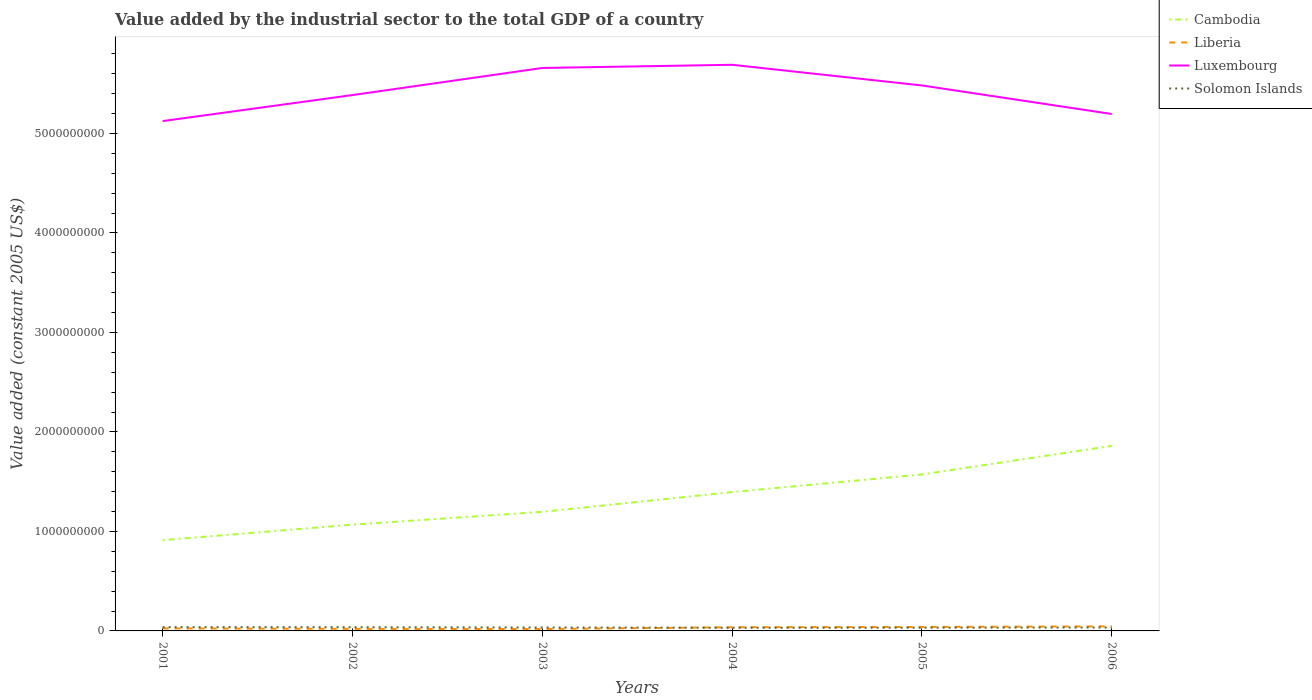How many different coloured lines are there?
Give a very brief answer. 4. Is the number of lines equal to the number of legend labels?
Offer a terse response. Yes. Across all years, what is the maximum value added by the industrial sector in Liberia?
Your response must be concise. 1.89e+07. What is the total value added by the industrial sector in Luxembourg in the graph?
Offer a very short reply. 4.95e+08. What is the difference between the highest and the second highest value added by the industrial sector in Liberia?
Ensure brevity in your answer.  2.71e+07. How many lines are there?
Ensure brevity in your answer.  4. How many years are there in the graph?
Your answer should be very brief. 6. What is the difference between two consecutive major ticks on the Y-axis?
Give a very brief answer. 1.00e+09. Are the values on the major ticks of Y-axis written in scientific E-notation?
Your answer should be compact. No. How many legend labels are there?
Offer a very short reply. 4. What is the title of the graph?
Provide a succinct answer. Value added by the industrial sector to the total GDP of a country. Does "Central Europe" appear as one of the legend labels in the graph?
Ensure brevity in your answer.  No. What is the label or title of the Y-axis?
Keep it short and to the point. Value added (constant 2005 US$). What is the Value added (constant 2005 US$) of Cambodia in 2001?
Offer a very short reply. 9.12e+08. What is the Value added (constant 2005 US$) of Liberia in 2001?
Provide a short and direct response. 2.54e+07. What is the Value added (constant 2005 US$) of Luxembourg in 2001?
Your answer should be very brief. 5.12e+09. What is the Value added (constant 2005 US$) in Solomon Islands in 2001?
Offer a very short reply. 3.80e+07. What is the Value added (constant 2005 US$) of Cambodia in 2002?
Give a very brief answer. 1.07e+09. What is the Value added (constant 2005 US$) in Liberia in 2002?
Your response must be concise. 2.10e+07. What is the Value added (constant 2005 US$) of Luxembourg in 2002?
Make the answer very short. 5.39e+09. What is the Value added (constant 2005 US$) of Solomon Islands in 2002?
Give a very brief answer. 3.70e+07. What is the Value added (constant 2005 US$) in Cambodia in 2003?
Provide a short and direct response. 1.20e+09. What is the Value added (constant 2005 US$) in Liberia in 2003?
Offer a very short reply. 1.89e+07. What is the Value added (constant 2005 US$) in Luxembourg in 2003?
Provide a short and direct response. 5.66e+09. What is the Value added (constant 2005 US$) in Solomon Islands in 2003?
Your response must be concise. 3.43e+07. What is the Value added (constant 2005 US$) of Cambodia in 2004?
Provide a short and direct response. 1.40e+09. What is the Value added (constant 2005 US$) of Liberia in 2004?
Ensure brevity in your answer.  3.69e+07. What is the Value added (constant 2005 US$) of Luxembourg in 2004?
Ensure brevity in your answer.  5.69e+09. What is the Value added (constant 2005 US$) of Solomon Islands in 2004?
Give a very brief answer. 3.20e+07. What is the Value added (constant 2005 US$) in Cambodia in 2005?
Keep it short and to the point. 1.57e+09. What is the Value added (constant 2005 US$) of Liberia in 2005?
Offer a very short reply. 3.97e+07. What is the Value added (constant 2005 US$) in Luxembourg in 2005?
Your response must be concise. 5.48e+09. What is the Value added (constant 2005 US$) in Solomon Islands in 2005?
Make the answer very short. 3.29e+07. What is the Value added (constant 2005 US$) in Cambodia in 2006?
Ensure brevity in your answer.  1.86e+09. What is the Value added (constant 2005 US$) of Liberia in 2006?
Provide a short and direct response. 4.59e+07. What is the Value added (constant 2005 US$) in Luxembourg in 2006?
Provide a short and direct response. 5.20e+09. What is the Value added (constant 2005 US$) in Solomon Islands in 2006?
Ensure brevity in your answer.  3.43e+07. Across all years, what is the maximum Value added (constant 2005 US$) of Cambodia?
Your response must be concise. 1.86e+09. Across all years, what is the maximum Value added (constant 2005 US$) in Liberia?
Make the answer very short. 4.59e+07. Across all years, what is the maximum Value added (constant 2005 US$) in Luxembourg?
Your answer should be compact. 5.69e+09. Across all years, what is the maximum Value added (constant 2005 US$) of Solomon Islands?
Ensure brevity in your answer.  3.80e+07. Across all years, what is the minimum Value added (constant 2005 US$) in Cambodia?
Make the answer very short. 9.12e+08. Across all years, what is the minimum Value added (constant 2005 US$) of Liberia?
Provide a succinct answer. 1.89e+07. Across all years, what is the minimum Value added (constant 2005 US$) of Luxembourg?
Offer a terse response. 5.12e+09. Across all years, what is the minimum Value added (constant 2005 US$) in Solomon Islands?
Ensure brevity in your answer.  3.20e+07. What is the total Value added (constant 2005 US$) of Cambodia in the graph?
Your answer should be very brief. 8.01e+09. What is the total Value added (constant 2005 US$) in Liberia in the graph?
Your response must be concise. 1.88e+08. What is the total Value added (constant 2005 US$) of Luxembourg in the graph?
Give a very brief answer. 3.25e+1. What is the total Value added (constant 2005 US$) of Solomon Islands in the graph?
Provide a short and direct response. 2.09e+08. What is the difference between the Value added (constant 2005 US$) of Cambodia in 2001 and that in 2002?
Ensure brevity in your answer.  -1.56e+08. What is the difference between the Value added (constant 2005 US$) in Liberia in 2001 and that in 2002?
Provide a succinct answer. 4.38e+06. What is the difference between the Value added (constant 2005 US$) of Luxembourg in 2001 and that in 2002?
Your response must be concise. -2.61e+08. What is the difference between the Value added (constant 2005 US$) of Solomon Islands in 2001 and that in 2002?
Give a very brief answer. 9.35e+05. What is the difference between the Value added (constant 2005 US$) of Cambodia in 2001 and that in 2003?
Make the answer very short. -2.84e+08. What is the difference between the Value added (constant 2005 US$) in Liberia in 2001 and that in 2003?
Your answer should be compact. 6.53e+06. What is the difference between the Value added (constant 2005 US$) of Luxembourg in 2001 and that in 2003?
Provide a succinct answer. -5.34e+08. What is the difference between the Value added (constant 2005 US$) of Solomon Islands in 2001 and that in 2003?
Your response must be concise. 3.68e+06. What is the difference between the Value added (constant 2005 US$) of Cambodia in 2001 and that in 2004?
Provide a succinct answer. -4.83e+08. What is the difference between the Value added (constant 2005 US$) of Liberia in 2001 and that in 2004?
Keep it short and to the point. -1.15e+07. What is the difference between the Value added (constant 2005 US$) in Luxembourg in 2001 and that in 2004?
Offer a very short reply. -5.66e+08. What is the difference between the Value added (constant 2005 US$) in Solomon Islands in 2001 and that in 2004?
Offer a terse response. 5.93e+06. What is the difference between the Value added (constant 2005 US$) in Cambodia in 2001 and that in 2005?
Provide a succinct answer. -6.60e+08. What is the difference between the Value added (constant 2005 US$) in Liberia in 2001 and that in 2005?
Ensure brevity in your answer.  -1.43e+07. What is the difference between the Value added (constant 2005 US$) in Luxembourg in 2001 and that in 2005?
Ensure brevity in your answer.  -3.58e+08. What is the difference between the Value added (constant 2005 US$) in Solomon Islands in 2001 and that in 2005?
Your response must be concise. 5.08e+06. What is the difference between the Value added (constant 2005 US$) of Cambodia in 2001 and that in 2006?
Your answer should be very brief. -9.48e+08. What is the difference between the Value added (constant 2005 US$) in Liberia in 2001 and that in 2006?
Keep it short and to the point. -2.05e+07. What is the difference between the Value added (constant 2005 US$) in Luxembourg in 2001 and that in 2006?
Your answer should be compact. -7.12e+07. What is the difference between the Value added (constant 2005 US$) of Solomon Islands in 2001 and that in 2006?
Give a very brief answer. 3.71e+06. What is the difference between the Value added (constant 2005 US$) in Cambodia in 2002 and that in 2003?
Provide a short and direct response. -1.29e+08. What is the difference between the Value added (constant 2005 US$) in Liberia in 2002 and that in 2003?
Your response must be concise. 2.14e+06. What is the difference between the Value added (constant 2005 US$) of Luxembourg in 2002 and that in 2003?
Ensure brevity in your answer.  -2.72e+08. What is the difference between the Value added (constant 2005 US$) of Solomon Islands in 2002 and that in 2003?
Your answer should be very brief. 2.74e+06. What is the difference between the Value added (constant 2005 US$) of Cambodia in 2002 and that in 2004?
Your answer should be very brief. -3.27e+08. What is the difference between the Value added (constant 2005 US$) of Liberia in 2002 and that in 2004?
Offer a terse response. -1.59e+07. What is the difference between the Value added (constant 2005 US$) of Luxembourg in 2002 and that in 2004?
Your answer should be compact. -3.04e+08. What is the difference between the Value added (constant 2005 US$) in Solomon Islands in 2002 and that in 2004?
Provide a succinct answer. 5.00e+06. What is the difference between the Value added (constant 2005 US$) in Cambodia in 2002 and that in 2005?
Your response must be concise. -5.05e+08. What is the difference between the Value added (constant 2005 US$) in Liberia in 2002 and that in 2005?
Keep it short and to the point. -1.87e+07. What is the difference between the Value added (constant 2005 US$) in Luxembourg in 2002 and that in 2005?
Your response must be concise. -9.65e+07. What is the difference between the Value added (constant 2005 US$) of Solomon Islands in 2002 and that in 2005?
Offer a very short reply. 4.15e+06. What is the difference between the Value added (constant 2005 US$) in Cambodia in 2002 and that in 2006?
Offer a terse response. -7.92e+08. What is the difference between the Value added (constant 2005 US$) of Liberia in 2002 and that in 2006?
Make the answer very short. -2.49e+07. What is the difference between the Value added (constant 2005 US$) of Luxembourg in 2002 and that in 2006?
Your answer should be compact. 1.90e+08. What is the difference between the Value added (constant 2005 US$) in Solomon Islands in 2002 and that in 2006?
Offer a terse response. 2.78e+06. What is the difference between the Value added (constant 2005 US$) of Cambodia in 2003 and that in 2004?
Your response must be concise. -1.99e+08. What is the difference between the Value added (constant 2005 US$) of Liberia in 2003 and that in 2004?
Provide a succinct answer. -1.81e+07. What is the difference between the Value added (constant 2005 US$) in Luxembourg in 2003 and that in 2004?
Ensure brevity in your answer.  -3.20e+07. What is the difference between the Value added (constant 2005 US$) of Solomon Islands in 2003 and that in 2004?
Offer a very short reply. 2.26e+06. What is the difference between the Value added (constant 2005 US$) of Cambodia in 2003 and that in 2005?
Ensure brevity in your answer.  -3.76e+08. What is the difference between the Value added (constant 2005 US$) of Liberia in 2003 and that in 2005?
Make the answer very short. -2.08e+07. What is the difference between the Value added (constant 2005 US$) in Luxembourg in 2003 and that in 2005?
Give a very brief answer. 1.76e+08. What is the difference between the Value added (constant 2005 US$) in Solomon Islands in 2003 and that in 2005?
Offer a very short reply. 1.41e+06. What is the difference between the Value added (constant 2005 US$) in Cambodia in 2003 and that in 2006?
Offer a very short reply. -6.63e+08. What is the difference between the Value added (constant 2005 US$) in Liberia in 2003 and that in 2006?
Offer a very short reply. -2.71e+07. What is the difference between the Value added (constant 2005 US$) of Luxembourg in 2003 and that in 2006?
Your answer should be compact. 4.63e+08. What is the difference between the Value added (constant 2005 US$) of Solomon Islands in 2003 and that in 2006?
Your answer should be compact. 3.70e+04. What is the difference between the Value added (constant 2005 US$) in Cambodia in 2004 and that in 2005?
Your response must be concise. -1.77e+08. What is the difference between the Value added (constant 2005 US$) in Liberia in 2004 and that in 2005?
Your answer should be compact. -2.78e+06. What is the difference between the Value added (constant 2005 US$) of Luxembourg in 2004 and that in 2005?
Provide a short and direct response. 2.08e+08. What is the difference between the Value added (constant 2005 US$) of Solomon Islands in 2004 and that in 2005?
Offer a very short reply. -8.51e+05. What is the difference between the Value added (constant 2005 US$) of Cambodia in 2004 and that in 2006?
Your answer should be compact. -4.65e+08. What is the difference between the Value added (constant 2005 US$) of Liberia in 2004 and that in 2006?
Your answer should be very brief. -8.99e+06. What is the difference between the Value added (constant 2005 US$) in Luxembourg in 2004 and that in 2006?
Provide a short and direct response. 4.95e+08. What is the difference between the Value added (constant 2005 US$) in Solomon Islands in 2004 and that in 2006?
Provide a succinct answer. -2.22e+06. What is the difference between the Value added (constant 2005 US$) of Cambodia in 2005 and that in 2006?
Your answer should be very brief. -2.87e+08. What is the difference between the Value added (constant 2005 US$) of Liberia in 2005 and that in 2006?
Your response must be concise. -6.21e+06. What is the difference between the Value added (constant 2005 US$) in Luxembourg in 2005 and that in 2006?
Your response must be concise. 2.87e+08. What is the difference between the Value added (constant 2005 US$) in Solomon Islands in 2005 and that in 2006?
Your answer should be compact. -1.37e+06. What is the difference between the Value added (constant 2005 US$) of Cambodia in 2001 and the Value added (constant 2005 US$) of Liberia in 2002?
Ensure brevity in your answer.  8.91e+08. What is the difference between the Value added (constant 2005 US$) of Cambodia in 2001 and the Value added (constant 2005 US$) of Luxembourg in 2002?
Give a very brief answer. -4.47e+09. What is the difference between the Value added (constant 2005 US$) in Cambodia in 2001 and the Value added (constant 2005 US$) in Solomon Islands in 2002?
Provide a succinct answer. 8.75e+08. What is the difference between the Value added (constant 2005 US$) in Liberia in 2001 and the Value added (constant 2005 US$) in Luxembourg in 2002?
Offer a terse response. -5.36e+09. What is the difference between the Value added (constant 2005 US$) in Liberia in 2001 and the Value added (constant 2005 US$) in Solomon Islands in 2002?
Your answer should be very brief. -1.17e+07. What is the difference between the Value added (constant 2005 US$) of Luxembourg in 2001 and the Value added (constant 2005 US$) of Solomon Islands in 2002?
Your answer should be compact. 5.09e+09. What is the difference between the Value added (constant 2005 US$) of Cambodia in 2001 and the Value added (constant 2005 US$) of Liberia in 2003?
Make the answer very short. 8.94e+08. What is the difference between the Value added (constant 2005 US$) of Cambodia in 2001 and the Value added (constant 2005 US$) of Luxembourg in 2003?
Ensure brevity in your answer.  -4.75e+09. What is the difference between the Value added (constant 2005 US$) in Cambodia in 2001 and the Value added (constant 2005 US$) in Solomon Islands in 2003?
Give a very brief answer. 8.78e+08. What is the difference between the Value added (constant 2005 US$) of Liberia in 2001 and the Value added (constant 2005 US$) of Luxembourg in 2003?
Your response must be concise. -5.63e+09. What is the difference between the Value added (constant 2005 US$) of Liberia in 2001 and the Value added (constant 2005 US$) of Solomon Islands in 2003?
Make the answer very short. -8.92e+06. What is the difference between the Value added (constant 2005 US$) in Luxembourg in 2001 and the Value added (constant 2005 US$) in Solomon Islands in 2003?
Give a very brief answer. 5.09e+09. What is the difference between the Value added (constant 2005 US$) in Cambodia in 2001 and the Value added (constant 2005 US$) in Liberia in 2004?
Your answer should be very brief. 8.76e+08. What is the difference between the Value added (constant 2005 US$) of Cambodia in 2001 and the Value added (constant 2005 US$) of Luxembourg in 2004?
Keep it short and to the point. -4.78e+09. What is the difference between the Value added (constant 2005 US$) in Cambodia in 2001 and the Value added (constant 2005 US$) in Solomon Islands in 2004?
Make the answer very short. 8.80e+08. What is the difference between the Value added (constant 2005 US$) of Liberia in 2001 and the Value added (constant 2005 US$) of Luxembourg in 2004?
Keep it short and to the point. -5.67e+09. What is the difference between the Value added (constant 2005 US$) of Liberia in 2001 and the Value added (constant 2005 US$) of Solomon Islands in 2004?
Your answer should be very brief. -6.66e+06. What is the difference between the Value added (constant 2005 US$) of Luxembourg in 2001 and the Value added (constant 2005 US$) of Solomon Islands in 2004?
Offer a very short reply. 5.09e+09. What is the difference between the Value added (constant 2005 US$) of Cambodia in 2001 and the Value added (constant 2005 US$) of Liberia in 2005?
Your answer should be compact. 8.73e+08. What is the difference between the Value added (constant 2005 US$) of Cambodia in 2001 and the Value added (constant 2005 US$) of Luxembourg in 2005?
Provide a short and direct response. -4.57e+09. What is the difference between the Value added (constant 2005 US$) of Cambodia in 2001 and the Value added (constant 2005 US$) of Solomon Islands in 2005?
Provide a succinct answer. 8.80e+08. What is the difference between the Value added (constant 2005 US$) in Liberia in 2001 and the Value added (constant 2005 US$) in Luxembourg in 2005?
Make the answer very short. -5.46e+09. What is the difference between the Value added (constant 2005 US$) in Liberia in 2001 and the Value added (constant 2005 US$) in Solomon Islands in 2005?
Keep it short and to the point. -7.51e+06. What is the difference between the Value added (constant 2005 US$) in Luxembourg in 2001 and the Value added (constant 2005 US$) in Solomon Islands in 2005?
Your answer should be very brief. 5.09e+09. What is the difference between the Value added (constant 2005 US$) in Cambodia in 2001 and the Value added (constant 2005 US$) in Liberia in 2006?
Provide a succinct answer. 8.67e+08. What is the difference between the Value added (constant 2005 US$) in Cambodia in 2001 and the Value added (constant 2005 US$) in Luxembourg in 2006?
Make the answer very short. -4.28e+09. What is the difference between the Value added (constant 2005 US$) of Cambodia in 2001 and the Value added (constant 2005 US$) of Solomon Islands in 2006?
Provide a short and direct response. 8.78e+08. What is the difference between the Value added (constant 2005 US$) in Liberia in 2001 and the Value added (constant 2005 US$) in Luxembourg in 2006?
Make the answer very short. -5.17e+09. What is the difference between the Value added (constant 2005 US$) of Liberia in 2001 and the Value added (constant 2005 US$) of Solomon Islands in 2006?
Ensure brevity in your answer.  -8.88e+06. What is the difference between the Value added (constant 2005 US$) in Luxembourg in 2001 and the Value added (constant 2005 US$) in Solomon Islands in 2006?
Your response must be concise. 5.09e+09. What is the difference between the Value added (constant 2005 US$) of Cambodia in 2002 and the Value added (constant 2005 US$) of Liberia in 2003?
Offer a terse response. 1.05e+09. What is the difference between the Value added (constant 2005 US$) of Cambodia in 2002 and the Value added (constant 2005 US$) of Luxembourg in 2003?
Offer a terse response. -4.59e+09. What is the difference between the Value added (constant 2005 US$) in Cambodia in 2002 and the Value added (constant 2005 US$) in Solomon Islands in 2003?
Keep it short and to the point. 1.03e+09. What is the difference between the Value added (constant 2005 US$) in Liberia in 2002 and the Value added (constant 2005 US$) in Luxembourg in 2003?
Your answer should be compact. -5.64e+09. What is the difference between the Value added (constant 2005 US$) in Liberia in 2002 and the Value added (constant 2005 US$) in Solomon Islands in 2003?
Give a very brief answer. -1.33e+07. What is the difference between the Value added (constant 2005 US$) in Luxembourg in 2002 and the Value added (constant 2005 US$) in Solomon Islands in 2003?
Provide a short and direct response. 5.35e+09. What is the difference between the Value added (constant 2005 US$) in Cambodia in 2002 and the Value added (constant 2005 US$) in Liberia in 2004?
Give a very brief answer. 1.03e+09. What is the difference between the Value added (constant 2005 US$) in Cambodia in 2002 and the Value added (constant 2005 US$) in Luxembourg in 2004?
Provide a succinct answer. -4.62e+09. What is the difference between the Value added (constant 2005 US$) of Cambodia in 2002 and the Value added (constant 2005 US$) of Solomon Islands in 2004?
Your response must be concise. 1.04e+09. What is the difference between the Value added (constant 2005 US$) in Liberia in 2002 and the Value added (constant 2005 US$) in Luxembourg in 2004?
Your answer should be very brief. -5.67e+09. What is the difference between the Value added (constant 2005 US$) of Liberia in 2002 and the Value added (constant 2005 US$) of Solomon Islands in 2004?
Provide a succinct answer. -1.10e+07. What is the difference between the Value added (constant 2005 US$) of Luxembourg in 2002 and the Value added (constant 2005 US$) of Solomon Islands in 2004?
Keep it short and to the point. 5.35e+09. What is the difference between the Value added (constant 2005 US$) of Cambodia in 2002 and the Value added (constant 2005 US$) of Liberia in 2005?
Ensure brevity in your answer.  1.03e+09. What is the difference between the Value added (constant 2005 US$) in Cambodia in 2002 and the Value added (constant 2005 US$) in Luxembourg in 2005?
Offer a very short reply. -4.41e+09. What is the difference between the Value added (constant 2005 US$) of Cambodia in 2002 and the Value added (constant 2005 US$) of Solomon Islands in 2005?
Make the answer very short. 1.04e+09. What is the difference between the Value added (constant 2005 US$) in Liberia in 2002 and the Value added (constant 2005 US$) in Luxembourg in 2005?
Keep it short and to the point. -5.46e+09. What is the difference between the Value added (constant 2005 US$) in Liberia in 2002 and the Value added (constant 2005 US$) in Solomon Islands in 2005?
Your answer should be compact. -1.19e+07. What is the difference between the Value added (constant 2005 US$) of Luxembourg in 2002 and the Value added (constant 2005 US$) of Solomon Islands in 2005?
Your answer should be compact. 5.35e+09. What is the difference between the Value added (constant 2005 US$) of Cambodia in 2002 and the Value added (constant 2005 US$) of Liberia in 2006?
Provide a short and direct response. 1.02e+09. What is the difference between the Value added (constant 2005 US$) in Cambodia in 2002 and the Value added (constant 2005 US$) in Luxembourg in 2006?
Ensure brevity in your answer.  -4.13e+09. What is the difference between the Value added (constant 2005 US$) in Cambodia in 2002 and the Value added (constant 2005 US$) in Solomon Islands in 2006?
Make the answer very short. 1.03e+09. What is the difference between the Value added (constant 2005 US$) of Liberia in 2002 and the Value added (constant 2005 US$) of Luxembourg in 2006?
Provide a short and direct response. -5.17e+09. What is the difference between the Value added (constant 2005 US$) of Liberia in 2002 and the Value added (constant 2005 US$) of Solomon Islands in 2006?
Your answer should be very brief. -1.33e+07. What is the difference between the Value added (constant 2005 US$) in Luxembourg in 2002 and the Value added (constant 2005 US$) in Solomon Islands in 2006?
Your response must be concise. 5.35e+09. What is the difference between the Value added (constant 2005 US$) in Cambodia in 2003 and the Value added (constant 2005 US$) in Liberia in 2004?
Offer a very short reply. 1.16e+09. What is the difference between the Value added (constant 2005 US$) of Cambodia in 2003 and the Value added (constant 2005 US$) of Luxembourg in 2004?
Offer a terse response. -4.49e+09. What is the difference between the Value added (constant 2005 US$) of Cambodia in 2003 and the Value added (constant 2005 US$) of Solomon Islands in 2004?
Offer a terse response. 1.16e+09. What is the difference between the Value added (constant 2005 US$) in Liberia in 2003 and the Value added (constant 2005 US$) in Luxembourg in 2004?
Give a very brief answer. -5.67e+09. What is the difference between the Value added (constant 2005 US$) in Liberia in 2003 and the Value added (constant 2005 US$) in Solomon Islands in 2004?
Your answer should be very brief. -1.32e+07. What is the difference between the Value added (constant 2005 US$) of Luxembourg in 2003 and the Value added (constant 2005 US$) of Solomon Islands in 2004?
Offer a very short reply. 5.63e+09. What is the difference between the Value added (constant 2005 US$) in Cambodia in 2003 and the Value added (constant 2005 US$) in Liberia in 2005?
Your answer should be compact. 1.16e+09. What is the difference between the Value added (constant 2005 US$) in Cambodia in 2003 and the Value added (constant 2005 US$) in Luxembourg in 2005?
Your response must be concise. -4.29e+09. What is the difference between the Value added (constant 2005 US$) in Cambodia in 2003 and the Value added (constant 2005 US$) in Solomon Islands in 2005?
Ensure brevity in your answer.  1.16e+09. What is the difference between the Value added (constant 2005 US$) of Liberia in 2003 and the Value added (constant 2005 US$) of Luxembourg in 2005?
Your answer should be very brief. -5.46e+09. What is the difference between the Value added (constant 2005 US$) of Liberia in 2003 and the Value added (constant 2005 US$) of Solomon Islands in 2005?
Offer a terse response. -1.40e+07. What is the difference between the Value added (constant 2005 US$) in Luxembourg in 2003 and the Value added (constant 2005 US$) in Solomon Islands in 2005?
Your answer should be very brief. 5.63e+09. What is the difference between the Value added (constant 2005 US$) in Cambodia in 2003 and the Value added (constant 2005 US$) in Liberia in 2006?
Provide a succinct answer. 1.15e+09. What is the difference between the Value added (constant 2005 US$) of Cambodia in 2003 and the Value added (constant 2005 US$) of Luxembourg in 2006?
Your response must be concise. -4.00e+09. What is the difference between the Value added (constant 2005 US$) in Cambodia in 2003 and the Value added (constant 2005 US$) in Solomon Islands in 2006?
Offer a very short reply. 1.16e+09. What is the difference between the Value added (constant 2005 US$) of Liberia in 2003 and the Value added (constant 2005 US$) of Luxembourg in 2006?
Provide a short and direct response. -5.18e+09. What is the difference between the Value added (constant 2005 US$) in Liberia in 2003 and the Value added (constant 2005 US$) in Solomon Islands in 2006?
Give a very brief answer. -1.54e+07. What is the difference between the Value added (constant 2005 US$) of Luxembourg in 2003 and the Value added (constant 2005 US$) of Solomon Islands in 2006?
Offer a very short reply. 5.62e+09. What is the difference between the Value added (constant 2005 US$) in Cambodia in 2004 and the Value added (constant 2005 US$) in Liberia in 2005?
Provide a succinct answer. 1.36e+09. What is the difference between the Value added (constant 2005 US$) in Cambodia in 2004 and the Value added (constant 2005 US$) in Luxembourg in 2005?
Offer a very short reply. -4.09e+09. What is the difference between the Value added (constant 2005 US$) in Cambodia in 2004 and the Value added (constant 2005 US$) in Solomon Islands in 2005?
Offer a terse response. 1.36e+09. What is the difference between the Value added (constant 2005 US$) in Liberia in 2004 and the Value added (constant 2005 US$) in Luxembourg in 2005?
Provide a succinct answer. -5.45e+09. What is the difference between the Value added (constant 2005 US$) in Liberia in 2004 and the Value added (constant 2005 US$) in Solomon Islands in 2005?
Give a very brief answer. 4.02e+06. What is the difference between the Value added (constant 2005 US$) in Luxembourg in 2004 and the Value added (constant 2005 US$) in Solomon Islands in 2005?
Your answer should be very brief. 5.66e+09. What is the difference between the Value added (constant 2005 US$) of Cambodia in 2004 and the Value added (constant 2005 US$) of Liberia in 2006?
Keep it short and to the point. 1.35e+09. What is the difference between the Value added (constant 2005 US$) of Cambodia in 2004 and the Value added (constant 2005 US$) of Luxembourg in 2006?
Ensure brevity in your answer.  -3.80e+09. What is the difference between the Value added (constant 2005 US$) of Cambodia in 2004 and the Value added (constant 2005 US$) of Solomon Islands in 2006?
Keep it short and to the point. 1.36e+09. What is the difference between the Value added (constant 2005 US$) in Liberia in 2004 and the Value added (constant 2005 US$) in Luxembourg in 2006?
Provide a succinct answer. -5.16e+09. What is the difference between the Value added (constant 2005 US$) of Liberia in 2004 and the Value added (constant 2005 US$) of Solomon Islands in 2006?
Give a very brief answer. 2.65e+06. What is the difference between the Value added (constant 2005 US$) in Luxembourg in 2004 and the Value added (constant 2005 US$) in Solomon Islands in 2006?
Keep it short and to the point. 5.66e+09. What is the difference between the Value added (constant 2005 US$) of Cambodia in 2005 and the Value added (constant 2005 US$) of Liberia in 2006?
Offer a very short reply. 1.53e+09. What is the difference between the Value added (constant 2005 US$) of Cambodia in 2005 and the Value added (constant 2005 US$) of Luxembourg in 2006?
Your answer should be compact. -3.62e+09. What is the difference between the Value added (constant 2005 US$) of Cambodia in 2005 and the Value added (constant 2005 US$) of Solomon Islands in 2006?
Provide a short and direct response. 1.54e+09. What is the difference between the Value added (constant 2005 US$) in Liberia in 2005 and the Value added (constant 2005 US$) in Luxembourg in 2006?
Make the answer very short. -5.16e+09. What is the difference between the Value added (constant 2005 US$) of Liberia in 2005 and the Value added (constant 2005 US$) of Solomon Islands in 2006?
Give a very brief answer. 5.43e+06. What is the difference between the Value added (constant 2005 US$) in Luxembourg in 2005 and the Value added (constant 2005 US$) in Solomon Islands in 2006?
Keep it short and to the point. 5.45e+09. What is the average Value added (constant 2005 US$) in Cambodia per year?
Ensure brevity in your answer.  1.33e+09. What is the average Value added (constant 2005 US$) in Liberia per year?
Offer a terse response. 3.13e+07. What is the average Value added (constant 2005 US$) of Luxembourg per year?
Give a very brief answer. 5.42e+09. What is the average Value added (constant 2005 US$) of Solomon Islands per year?
Make the answer very short. 3.48e+07. In the year 2001, what is the difference between the Value added (constant 2005 US$) in Cambodia and Value added (constant 2005 US$) in Liberia?
Provide a short and direct response. 8.87e+08. In the year 2001, what is the difference between the Value added (constant 2005 US$) in Cambodia and Value added (constant 2005 US$) in Luxembourg?
Provide a short and direct response. -4.21e+09. In the year 2001, what is the difference between the Value added (constant 2005 US$) in Cambodia and Value added (constant 2005 US$) in Solomon Islands?
Make the answer very short. 8.74e+08. In the year 2001, what is the difference between the Value added (constant 2005 US$) in Liberia and Value added (constant 2005 US$) in Luxembourg?
Your answer should be compact. -5.10e+09. In the year 2001, what is the difference between the Value added (constant 2005 US$) in Liberia and Value added (constant 2005 US$) in Solomon Islands?
Keep it short and to the point. -1.26e+07. In the year 2001, what is the difference between the Value added (constant 2005 US$) in Luxembourg and Value added (constant 2005 US$) in Solomon Islands?
Provide a succinct answer. 5.09e+09. In the year 2002, what is the difference between the Value added (constant 2005 US$) of Cambodia and Value added (constant 2005 US$) of Liberia?
Offer a very short reply. 1.05e+09. In the year 2002, what is the difference between the Value added (constant 2005 US$) of Cambodia and Value added (constant 2005 US$) of Luxembourg?
Your response must be concise. -4.32e+09. In the year 2002, what is the difference between the Value added (constant 2005 US$) of Cambodia and Value added (constant 2005 US$) of Solomon Islands?
Your answer should be compact. 1.03e+09. In the year 2002, what is the difference between the Value added (constant 2005 US$) of Liberia and Value added (constant 2005 US$) of Luxembourg?
Offer a very short reply. -5.37e+09. In the year 2002, what is the difference between the Value added (constant 2005 US$) in Liberia and Value added (constant 2005 US$) in Solomon Islands?
Provide a succinct answer. -1.60e+07. In the year 2002, what is the difference between the Value added (constant 2005 US$) in Luxembourg and Value added (constant 2005 US$) in Solomon Islands?
Provide a succinct answer. 5.35e+09. In the year 2003, what is the difference between the Value added (constant 2005 US$) of Cambodia and Value added (constant 2005 US$) of Liberia?
Your response must be concise. 1.18e+09. In the year 2003, what is the difference between the Value added (constant 2005 US$) of Cambodia and Value added (constant 2005 US$) of Luxembourg?
Your answer should be very brief. -4.46e+09. In the year 2003, what is the difference between the Value added (constant 2005 US$) of Cambodia and Value added (constant 2005 US$) of Solomon Islands?
Your answer should be very brief. 1.16e+09. In the year 2003, what is the difference between the Value added (constant 2005 US$) in Liberia and Value added (constant 2005 US$) in Luxembourg?
Keep it short and to the point. -5.64e+09. In the year 2003, what is the difference between the Value added (constant 2005 US$) of Liberia and Value added (constant 2005 US$) of Solomon Islands?
Your answer should be very brief. -1.54e+07. In the year 2003, what is the difference between the Value added (constant 2005 US$) of Luxembourg and Value added (constant 2005 US$) of Solomon Islands?
Provide a succinct answer. 5.62e+09. In the year 2004, what is the difference between the Value added (constant 2005 US$) of Cambodia and Value added (constant 2005 US$) of Liberia?
Keep it short and to the point. 1.36e+09. In the year 2004, what is the difference between the Value added (constant 2005 US$) in Cambodia and Value added (constant 2005 US$) in Luxembourg?
Your response must be concise. -4.29e+09. In the year 2004, what is the difference between the Value added (constant 2005 US$) in Cambodia and Value added (constant 2005 US$) in Solomon Islands?
Ensure brevity in your answer.  1.36e+09. In the year 2004, what is the difference between the Value added (constant 2005 US$) of Liberia and Value added (constant 2005 US$) of Luxembourg?
Offer a very short reply. -5.65e+09. In the year 2004, what is the difference between the Value added (constant 2005 US$) in Liberia and Value added (constant 2005 US$) in Solomon Islands?
Your answer should be very brief. 4.87e+06. In the year 2004, what is the difference between the Value added (constant 2005 US$) of Luxembourg and Value added (constant 2005 US$) of Solomon Islands?
Ensure brevity in your answer.  5.66e+09. In the year 2005, what is the difference between the Value added (constant 2005 US$) of Cambodia and Value added (constant 2005 US$) of Liberia?
Your response must be concise. 1.53e+09. In the year 2005, what is the difference between the Value added (constant 2005 US$) in Cambodia and Value added (constant 2005 US$) in Luxembourg?
Offer a very short reply. -3.91e+09. In the year 2005, what is the difference between the Value added (constant 2005 US$) in Cambodia and Value added (constant 2005 US$) in Solomon Islands?
Offer a terse response. 1.54e+09. In the year 2005, what is the difference between the Value added (constant 2005 US$) in Liberia and Value added (constant 2005 US$) in Luxembourg?
Provide a succinct answer. -5.44e+09. In the year 2005, what is the difference between the Value added (constant 2005 US$) of Liberia and Value added (constant 2005 US$) of Solomon Islands?
Your answer should be compact. 6.80e+06. In the year 2005, what is the difference between the Value added (constant 2005 US$) in Luxembourg and Value added (constant 2005 US$) in Solomon Islands?
Provide a short and direct response. 5.45e+09. In the year 2006, what is the difference between the Value added (constant 2005 US$) of Cambodia and Value added (constant 2005 US$) of Liberia?
Provide a succinct answer. 1.81e+09. In the year 2006, what is the difference between the Value added (constant 2005 US$) of Cambodia and Value added (constant 2005 US$) of Luxembourg?
Give a very brief answer. -3.34e+09. In the year 2006, what is the difference between the Value added (constant 2005 US$) in Cambodia and Value added (constant 2005 US$) in Solomon Islands?
Ensure brevity in your answer.  1.83e+09. In the year 2006, what is the difference between the Value added (constant 2005 US$) of Liberia and Value added (constant 2005 US$) of Luxembourg?
Offer a terse response. -5.15e+09. In the year 2006, what is the difference between the Value added (constant 2005 US$) of Liberia and Value added (constant 2005 US$) of Solomon Islands?
Give a very brief answer. 1.16e+07. In the year 2006, what is the difference between the Value added (constant 2005 US$) in Luxembourg and Value added (constant 2005 US$) in Solomon Islands?
Your response must be concise. 5.16e+09. What is the ratio of the Value added (constant 2005 US$) in Cambodia in 2001 to that in 2002?
Make the answer very short. 0.85. What is the ratio of the Value added (constant 2005 US$) in Liberia in 2001 to that in 2002?
Make the answer very short. 1.21. What is the ratio of the Value added (constant 2005 US$) in Luxembourg in 2001 to that in 2002?
Your answer should be very brief. 0.95. What is the ratio of the Value added (constant 2005 US$) in Solomon Islands in 2001 to that in 2002?
Make the answer very short. 1.03. What is the ratio of the Value added (constant 2005 US$) of Cambodia in 2001 to that in 2003?
Offer a very short reply. 0.76. What is the ratio of the Value added (constant 2005 US$) of Liberia in 2001 to that in 2003?
Ensure brevity in your answer.  1.35. What is the ratio of the Value added (constant 2005 US$) of Luxembourg in 2001 to that in 2003?
Offer a very short reply. 0.91. What is the ratio of the Value added (constant 2005 US$) of Solomon Islands in 2001 to that in 2003?
Offer a very short reply. 1.11. What is the ratio of the Value added (constant 2005 US$) of Cambodia in 2001 to that in 2004?
Keep it short and to the point. 0.65. What is the ratio of the Value added (constant 2005 US$) in Liberia in 2001 to that in 2004?
Make the answer very short. 0.69. What is the ratio of the Value added (constant 2005 US$) in Luxembourg in 2001 to that in 2004?
Give a very brief answer. 0.9. What is the ratio of the Value added (constant 2005 US$) of Solomon Islands in 2001 to that in 2004?
Make the answer very short. 1.19. What is the ratio of the Value added (constant 2005 US$) of Cambodia in 2001 to that in 2005?
Make the answer very short. 0.58. What is the ratio of the Value added (constant 2005 US$) of Liberia in 2001 to that in 2005?
Keep it short and to the point. 0.64. What is the ratio of the Value added (constant 2005 US$) of Luxembourg in 2001 to that in 2005?
Keep it short and to the point. 0.93. What is the ratio of the Value added (constant 2005 US$) in Solomon Islands in 2001 to that in 2005?
Provide a short and direct response. 1.15. What is the ratio of the Value added (constant 2005 US$) in Cambodia in 2001 to that in 2006?
Provide a short and direct response. 0.49. What is the ratio of the Value added (constant 2005 US$) in Liberia in 2001 to that in 2006?
Make the answer very short. 0.55. What is the ratio of the Value added (constant 2005 US$) of Luxembourg in 2001 to that in 2006?
Your answer should be compact. 0.99. What is the ratio of the Value added (constant 2005 US$) of Solomon Islands in 2001 to that in 2006?
Offer a terse response. 1.11. What is the ratio of the Value added (constant 2005 US$) of Cambodia in 2002 to that in 2003?
Offer a terse response. 0.89. What is the ratio of the Value added (constant 2005 US$) of Liberia in 2002 to that in 2003?
Your answer should be very brief. 1.11. What is the ratio of the Value added (constant 2005 US$) of Luxembourg in 2002 to that in 2003?
Provide a succinct answer. 0.95. What is the ratio of the Value added (constant 2005 US$) of Solomon Islands in 2002 to that in 2003?
Make the answer very short. 1.08. What is the ratio of the Value added (constant 2005 US$) in Cambodia in 2002 to that in 2004?
Offer a terse response. 0.77. What is the ratio of the Value added (constant 2005 US$) in Liberia in 2002 to that in 2004?
Provide a short and direct response. 0.57. What is the ratio of the Value added (constant 2005 US$) of Luxembourg in 2002 to that in 2004?
Your answer should be very brief. 0.95. What is the ratio of the Value added (constant 2005 US$) of Solomon Islands in 2002 to that in 2004?
Keep it short and to the point. 1.16. What is the ratio of the Value added (constant 2005 US$) of Cambodia in 2002 to that in 2005?
Keep it short and to the point. 0.68. What is the ratio of the Value added (constant 2005 US$) in Liberia in 2002 to that in 2005?
Your answer should be compact. 0.53. What is the ratio of the Value added (constant 2005 US$) of Luxembourg in 2002 to that in 2005?
Offer a terse response. 0.98. What is the ratio of the Value added (constant 2005 US$) of Solomon Islands in 2002 to that in 2005?
Offer a terse response. 1.13. What is the ratio of the Value added (constant 2005 US$) in Cambodia in 2002 to that in 2006?
Your answer should be very brief. 0.57. What is the ratio of the Value added (constant 2005 US$) of Liberia in 2002 to that in 2006?
Provide a succinct answer. 0.46. What is the ratio of the Value added (constant 2005 US$) in Luxembourg in 2002 to that in 2006?
Make the answer very short. 1.04. What is the ratio of the Value added (constant 2005 US$) of Solomon Islands in 2002 to that in 2006?
Your response must be concise. 1.08. What is the ratio of the Value added (constant 2005 US$) of Cambodia in 2003 to that in 2004?
Ensure brevity in your answer.  0.86. What is the ratio of the Value added (constant 2005 US$) in Liberia in 2003 to that in 2004?
Keep it short and to the point. 0.51. What is the ratio of the Value added (constant 2005 US$) in Luxembourg in 2003 to that in 2004?
Make the answer very short. 0.99. What is the ratio of the Value added (constant 2005 US$) in Solomon Islands in 2003 to that in 2004?
Your answer should be compact. 1.07. What is the ratio of the Value added (constant 2005 US$) in Cambodia in 2003 to that in 2005?
Your answer should be compact. 0.76. What is the ratio of the Value added (constant 2005 US$) in Liberia in 2003 to that in 2005?
Ensure brevity in your answer.  0.47. What is the ratio of the Value added (constant 2005 US$) of Luxembourg in 2003 to that in 2005?
Offer a very short reply. 1.03. What is the ratio of the Value added (constant 2005 US$) of Solomon Islands in 2003 to that in 2005?
Your response must be concise. 1.04. What is the ratio of the Value added (constant 2005 US$) of Cambodia in 2003 to that in 2006?
Your response must be concise. 0.64. What is the ratio of the Value added (constant 2005 US$) in Liberia in 2003 to that in 2006?
Offer a terse response. 0.41. What is the ratio of the Value added (constant 2005 US$) of Luxembourg in 2003 to that in 2006?
Provide a short and direct response. 1.09. What is the ratio of the Value added (constant 2005 US$) of Solomon Islands in 2003 to that in 2006?
Your response must be concise. 1. What is the ratio of the Value added (constant 2005 US$) in Cambodia in 2004 to that in 2005?
Your answer should be compact. 0.89. What is the ratio of the Value added (constant 2005 US$) in Luxembourg in 2004 to that in 2005?
Ensure brevity in your answer.  1.04. What is the ratio of the Value added (constant 2005 US$) of Solomon Islands in 2004 to that in 2005?
Provide a short and direct response. 0.97. What is the ratio of the Value added (constant 2005 US$) of Cambodia in 2004 to that in 2006?
Offer a very short reply. 0.75. What is the ratio of the Value added (constant 2005 US$) in Liberia in 2004 to that in 2006?
Give a very brief answer. 0.8. What is the ratio of the Value added (constant 2005 US$) in Luxembourg in 2004 to that in 2006?
Give a very brief answer. 1.1. What is the ratio of the Value added (constant 2005 US$) of Solomon Islands in 2004 to that in 2006?
Keep it short and to the point. 0.94. What is the ratio of the Value added (constant 2005 US$) in Cambodia in 2005 to that in 2006?
Your response must be concise. 0.85. What is the ratio of the Value added (constant 2005 US$) of Liberia in 2005 to that in 2006?
Keep it short and to the point. 0.86. What is the ratio of the Value added (constant 2005 US$) of Luxembourg in 2005 to that in 2006?
Provide a succinct answer. 1.06. What is the ratio of the Value added (constant 2005 US$) in Solomon Islands in 2005 to that in 2006?
Offer a very short reply. 0.96. What is the difference between the highest and the second highest Value added (constant 2005 US$) of Cambodia?
Make the answer very short. 2.87e+08. What is the difference between the highest and the second highest Value added (constant 2005 US$) in Liberia?
Provide a short and direct response. 6.21e+06. What is the difference between the highest and the second highest Value added (constant 2005 US$) in Luxembourg?
Offer a terse response. 3.20e+07. What is the difference between the highest and the second highest Value added (constant 2005 US$) in Solomon Islands?
Ensure brevity in your answer.  9.35e+05. What is the difference between the highest and the lowest Value added (constant 2005 US$) in Cambodia?
Make the answer very short. 9.48e+08. What is the difference between the highest and the lowest Value added (constant 2005 US$) of Liberia?
Your answer should be compact. 2.71e+07. What is the difference between the highest and the lowest Value added (constant 2005 US$) of Luxembourg?
Offer a very short reply. 5.66e+08. What is the difference between the highest and the lowest Value added (constant 2005 US$) of Solomon Islands?
Give a very brief answer. 5.93e+06. 